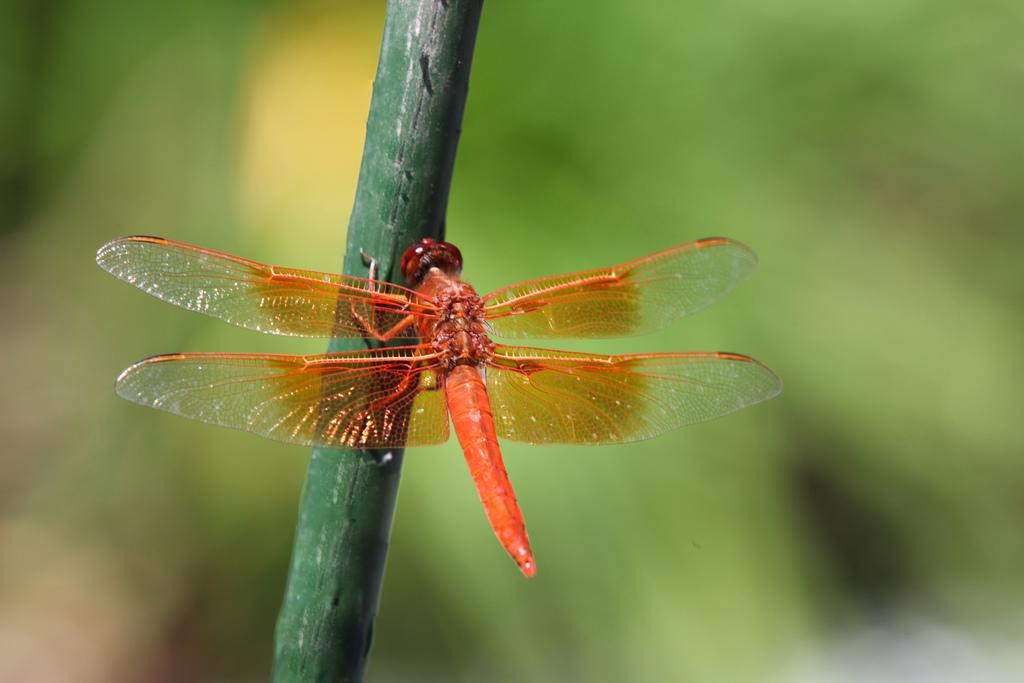What is present in the image? There is an insect in the image. Where is the insect located? The insect is on a plant. Can you describe the background of the image? The background of the image is blurred. What type of brush can be seen in the image? There is no brush present in the image. Are there any rails visible in the image? There are no rails present in the image. 